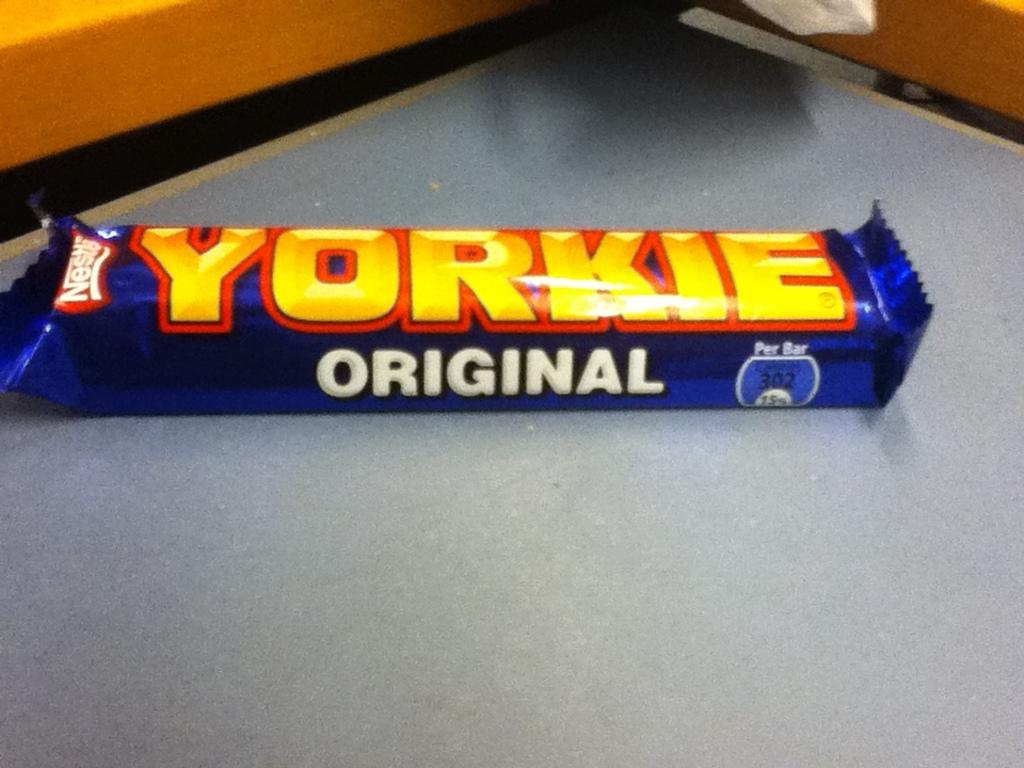Is this the original kind?
Your response must be concise. Yes. 